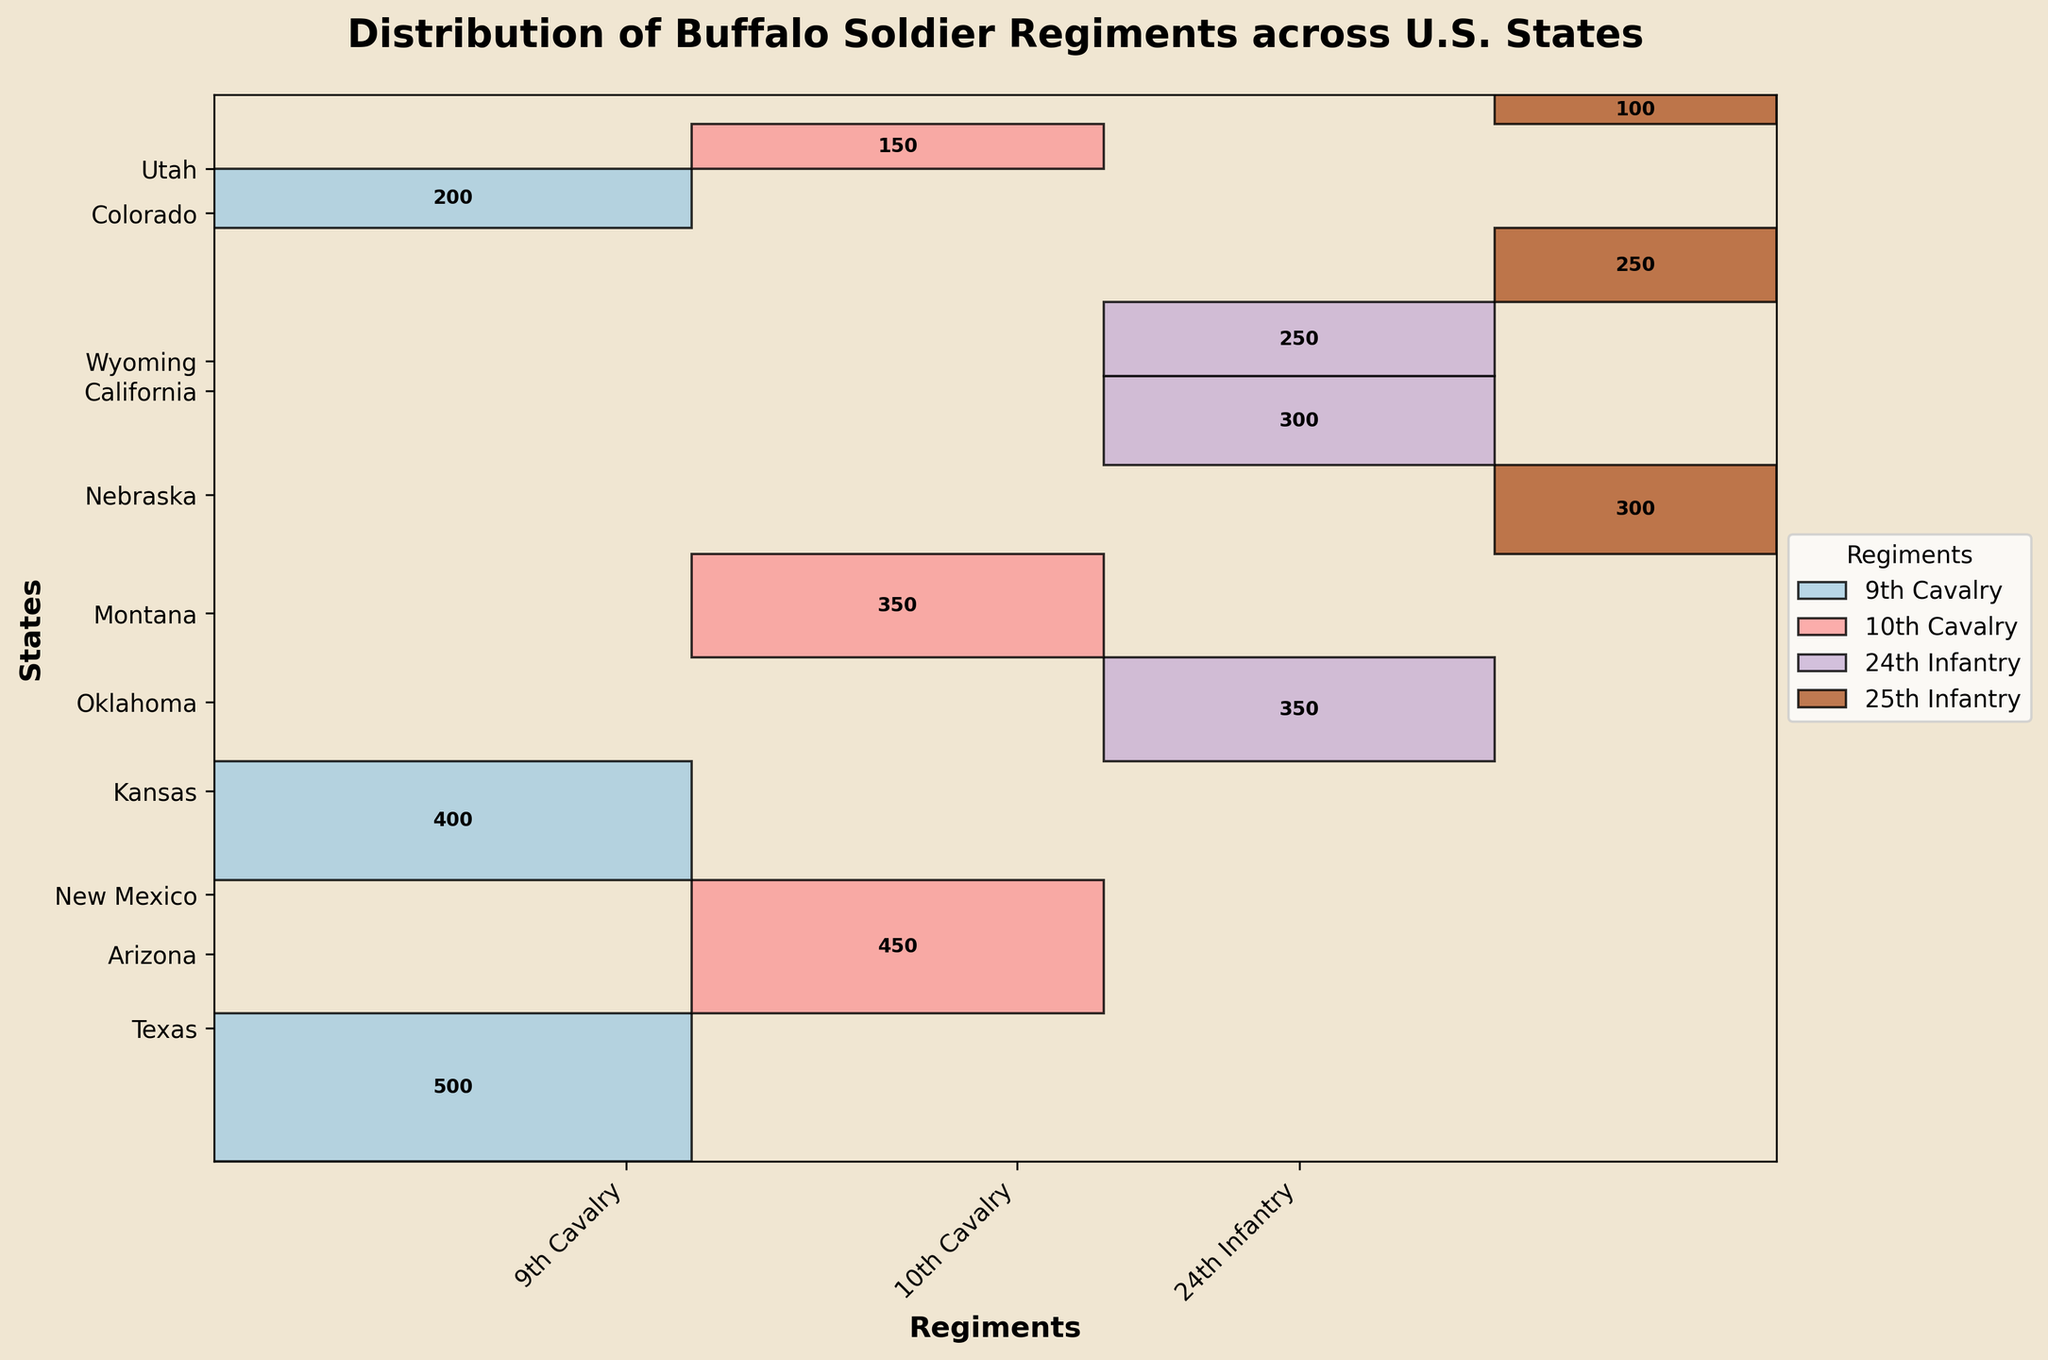What's the title of the plot? The title is typically located at the top of the plot and provides a brief description of what the plot represents. For this plot, the title is clearly stated.
Answer: Distribution of Buffalo Soldier Regiments across U.S. States Which regiment has the most number of soldiers overall? By comparing the widths of the rectangles for each regiment, the 9th Cavalry appears to have the widest representation, indicating the highest number of soldiers.
Answer: 9th Cavalry Which state has the largest total number of Buffalo Soldier regiments? Looking at the heights of the rectangles for each state, Texas appears to have the tallest representation, indicating the highest number of Buffalo Soldier regiments.
Answer: Texas How many soldiers are there in Arizona serving in the 10th Cavalry? The annotation inside the rectangle corresponding to Arizona and the 10th Cavalry will show the exact number of soldiers.
Answer: 450 Which state has the smallest height representation in the plot? By comparing the heights of all state segments in the plot, South Dakota has the smallest height representation.
Answer: South Dakota What is the total number of soldiers in the 25th Infantry across all states? Summing up the annotated numbers for the 25th Infantry in all states: 300 (Montana) + 250 (Wyoming) + 100 (South Dakota) = 650
Answer: 650 Compare the number of soldiers in the 10th Cavalry in Arizona and Utah. By looking at the annotations within the rectangles for Arizona and Utah in the 10th Cavalry: 450 (Arizona) and 150 (Utah). This shows that Arizona has more soldiers than Utah.
Answer: Arizona has more soldiers Which regiment has the least representation in Wyoming? The regiment with the smallest rectangle width in Wyoming represents the fewest soldiers. By comparing, the 24th Infantry has no soldiers in Wyoming.
Answer: 24th Infantry How does the number of soldiers in Texas' 9th Cavalry compare to that of New Mexico's 9th Cavalry? Looking at the annotations within the rectangles for the 9th Cavalry in Texas and New Mexico, Texas has 500 soldiers while New Mexico has 400. Thus, Texas has more soldiers.
Answer: Texas has more soldiers What is the total number of soldiers in Kansas from all regiments? Summing the soldiers in Kansas across all regiments: 350 (24th Infantry)
Answer: 350 